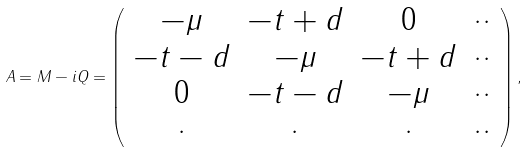Convert formula to latex. <formula><loc_0><loc_0><loc_500><loc_500>A = M - i Q = \left ( \begin{array} { c c c c } - \mu & - t + d & 0 & \cdot \cdot \\ - t - d & - \mu & - t + d & \cdot \cdot \\ 0 & - t - d & - \mu & \cdot \cdot \\ \cdot & \cdot & \cdot & \cdot \cdot \end{array} \right ) ,</formula> 